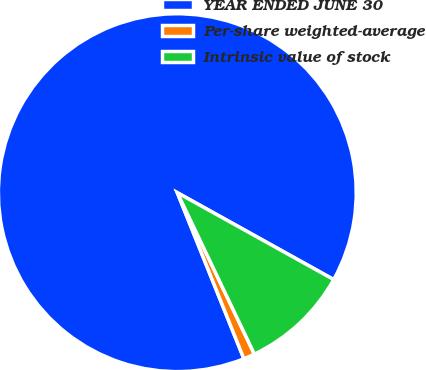Convert chart. <chart><loc_0><loc_0><loc_500><loc_500><pie_chart><fcel>YEAR ENDED JUNE 30<fcel>Per-share weighted-average<fcel>Intrinsic value of stock<nl><fcel>89.14%<fcel>1.02%<fcel>9.84%<nl></chart> 